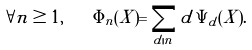Convert formula to latex. <formula><loc_0><loc_0><loc_500><loc_500>\forall n \geq 1 , \quad \Phi _ { n } ( X ) = \sum _ { d | n } d \, \Psi _ { d } ( X ) .</formula> 